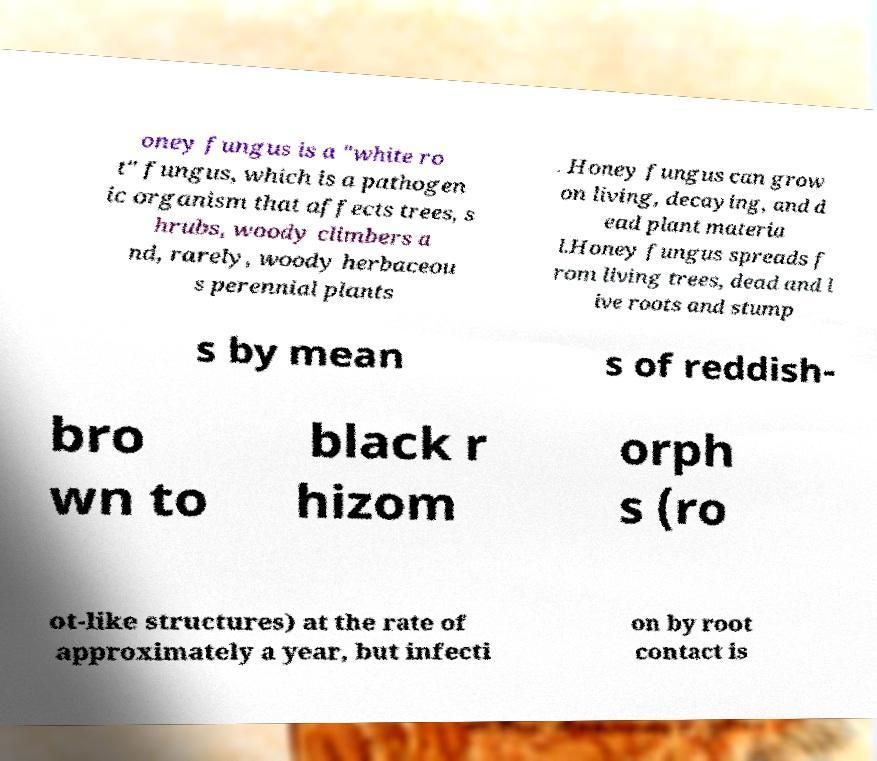What messages or text are displayed in this image? I need them in a readable, typed format. oney fungus is a "white ro t" fungus, which is a pathogen ic organism that affects trees, s hrubs, woody climbers a nd, rarely, woody herbaceou s perennial plants . Honey fungus can grow on living, decaying, and d ead plant materia l.Honey fungus spreads f rom living trees, dead and l ive roots and stump s by mean s of reddish- bro wn to black r hizom orph s (ro ot-like structures) at the rate of approximately a year, but infecti on by root contact is 